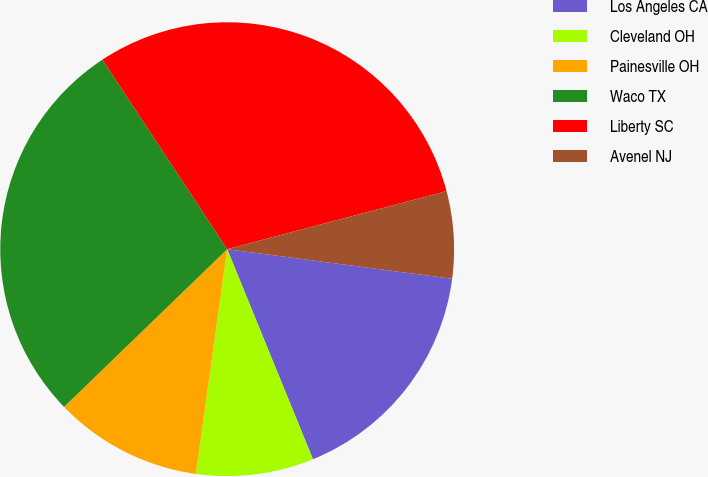Convert chart to OTSL. <chart><loc_0><loc_0><loc_500><loc_500><pie_chart><fcel>Los Angeles CA<fcel>Cleveland OH<fcel>Painesville OH<fcel>Waco TX<fcel>Liberty SC<fcel>Avenel NJ<nl><fcel>16.75%<fcel>8.38%<fcel>10.56%<fcel>27.97%<fcel>30.15%<fcel>6.2%<nl></chart> 